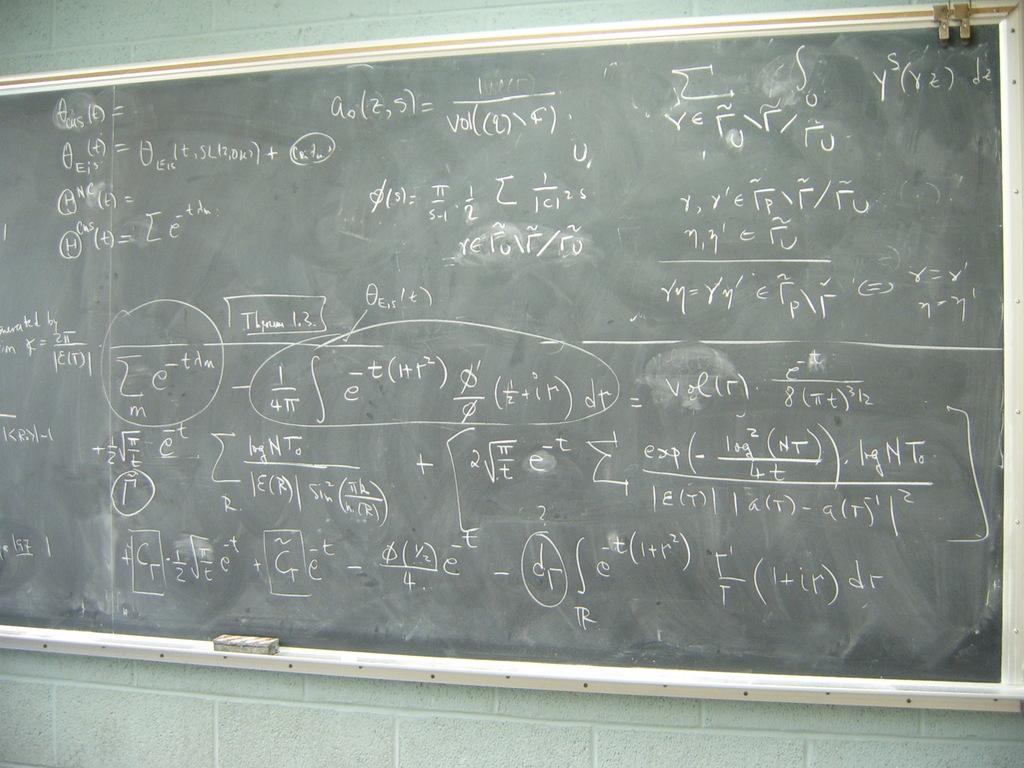What are the last 2 letters on the chalk board?
Ensure brevity in your answer.  Dr. What letters/numbers are in parentheses before the last two letters on the chalk board?
Your answer should be compact. 1 + ir. 